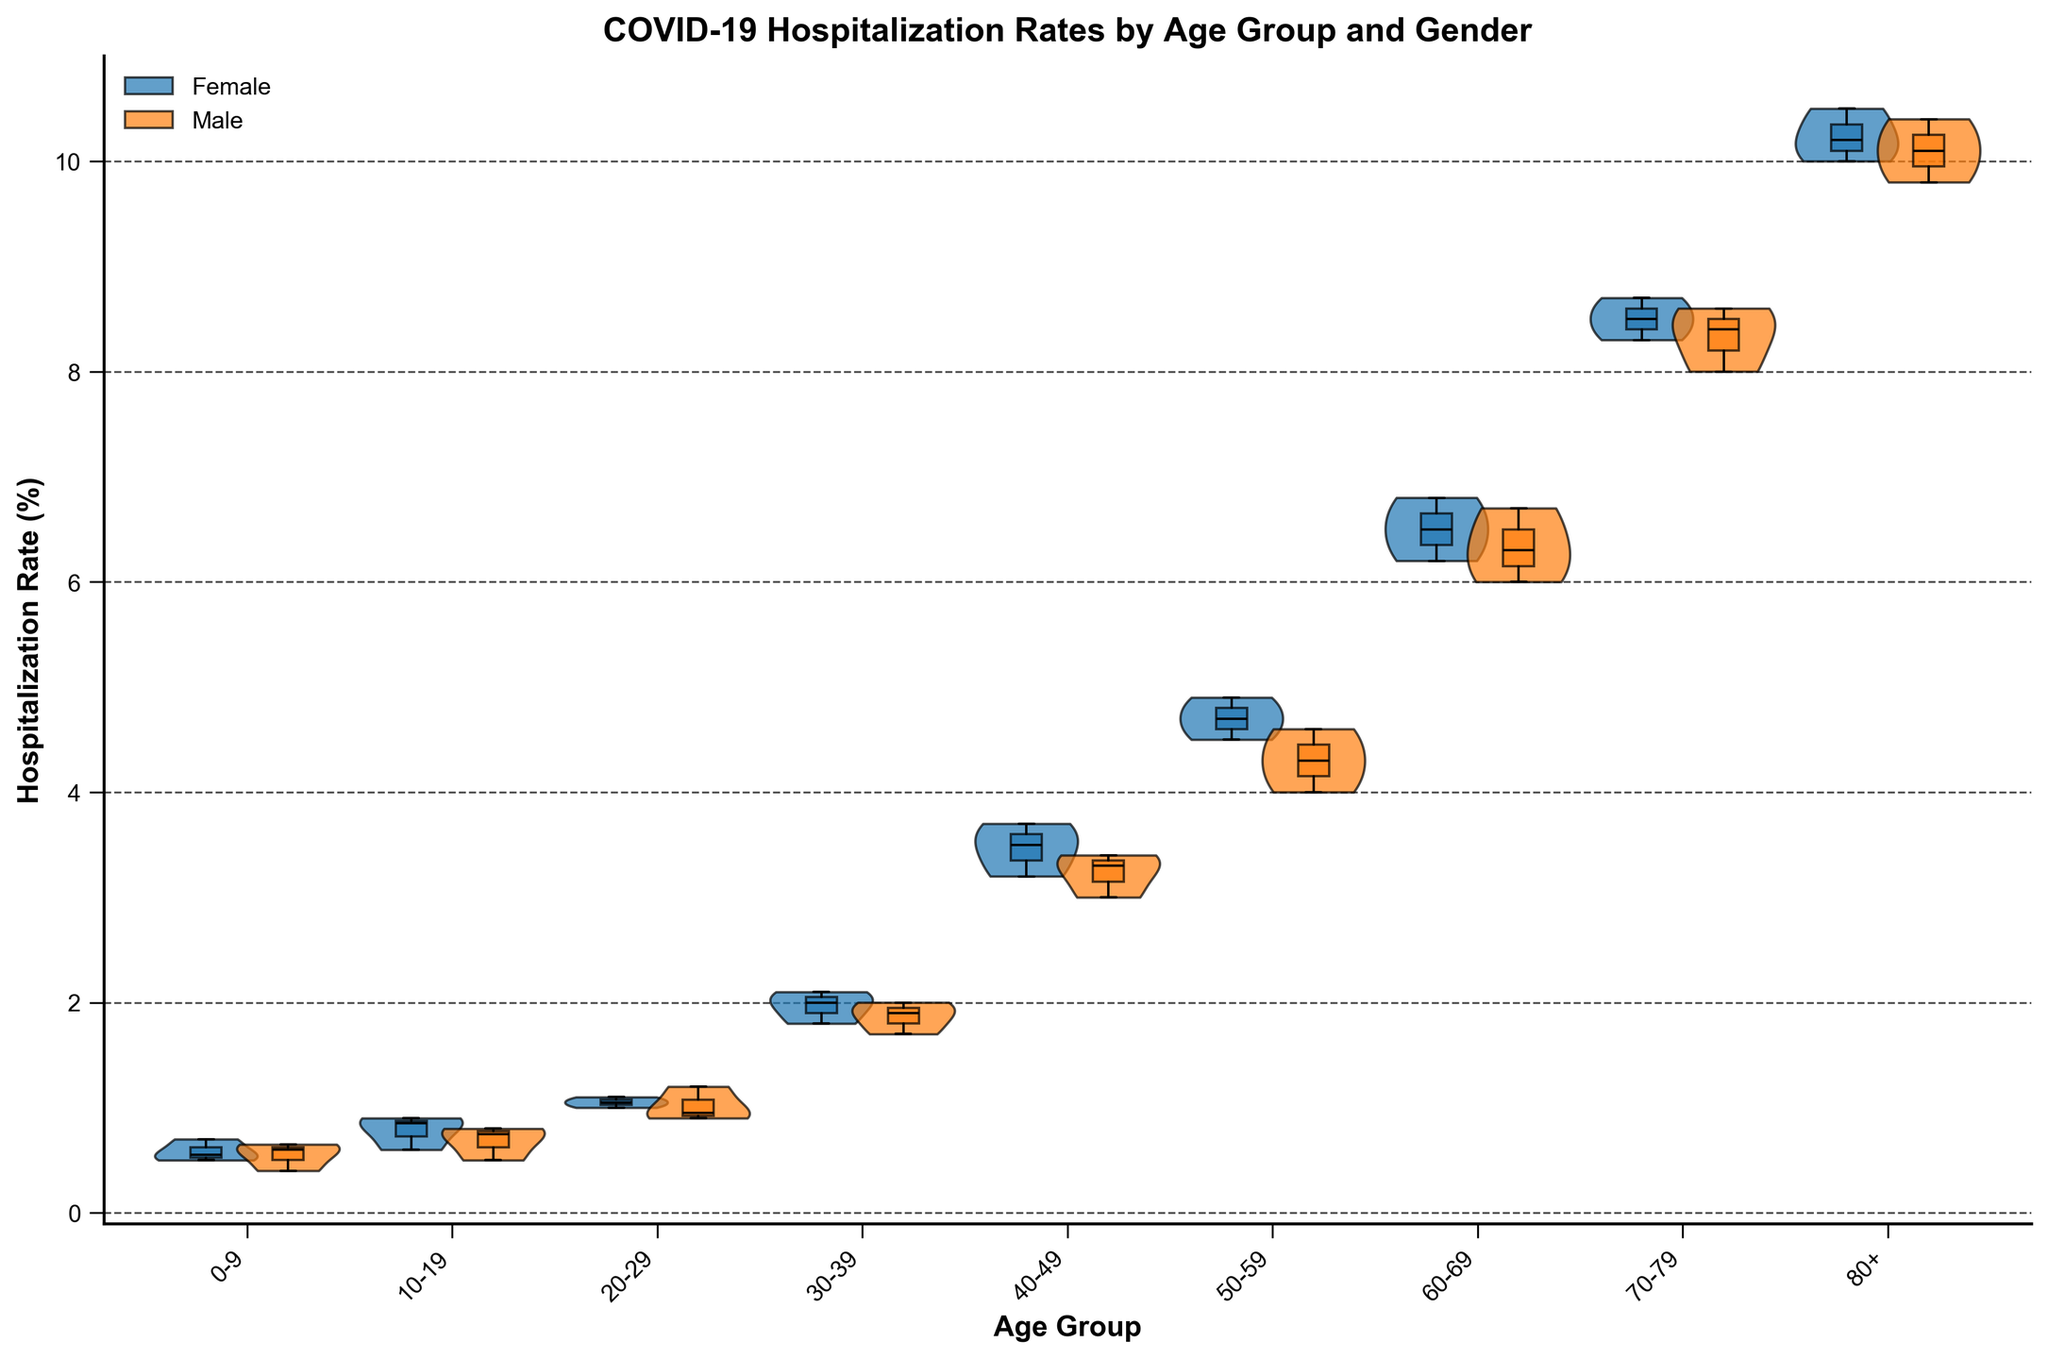What is the title of the figure? The title is usually displayed at the top of the figure. Here, it reads "COVID-19 Hospitalization Rates by Age Group and Gender."
Answer: COVID-19 Hospitalization Rates by Age Group and Gender What is the hospitalization rate range for the age group 50-59 years for females? For the age group 50-59 years, the box plot shows the interquartile range and median hospitalization rate for females (the colored box). The ends of the box signify the lower and upper quartiles (4.5 and 4.9), and the line inside the box indicates the median (4.7).
Answer: 4.5 to 4.9 Which age group shows the highest median hospitalization rate? To determine this, we look at the box plot component of each age group's violin plot and identify the one with the highest median line. For both genders, the age group "80+" has the highest median at around 10.3 for females and 10.1 for males.
Answer: 80+ Which gender has a higher median hospitalization rate in the 30-39 age group? By examining the box plots for the 30-39 age group, we compare the median lines. The female median (around 2.0) is slightly higher than the male median (around 1.9).
Answer: Female What are the interquartile ranges (IQR) for males and females in the 70-79 age group? The IQR is the difference between the upper quartile (75th percentile) and the lower quartile (25th percentile). For females in the 70-79 group, the IQR is 8.7 - 8.3 = 0.4. For males, it is 8.6 - 8.0 = 0.6.
Answer: Females: 0.4, Males: 0.6 Which age group has the smallest overall range in hospitalization rates for males? The overall range is the difference between the maximum and minimum values in the violin plot. For males, the 0-9 age group has rates (0.4 to 0.65), resulting in a range of 0.25, which is the smallest compared to other age groups.
Answer: 0-9 How does the spread of hospitalization rates compare between genders in the 60-69 age group? The spread can be observed via the width of the violin plots and the range of the box plots. Both the interquartile range and overall range (box plot and violin plot spread) for males and females in the 60-69 group are relatively similar, with females just slightly wider.
Answer: Similar spread with females slightly wider Are there any age groups where males and females have overlapping interquartile ranges? We need to check the box plots for any overlapping between the IQR for males and females. For example, in the 20-29 age group, the IQRs of both genders overlap since the upper quartile of males (1.2) intersects the lower quartile of females (1.0).
Answer: Yes, in the 20-29 age group In which age group is the male hospitalization rate's interquartile range (IQR) the widest? The IQR is visually determined by the box plot width. The widest IQR for males is in the 80+ age group (10.4 - 9.8 = 0.6).
Answer: 80+ What can we infer about the trend in hospitalization rates as age increases? By examining the medians in the box plots across age groups, we can see that hospitalization rates increase with age for both genders, implying higher vulnerability or severity in older age groups.
Answer: Rates increase with age 